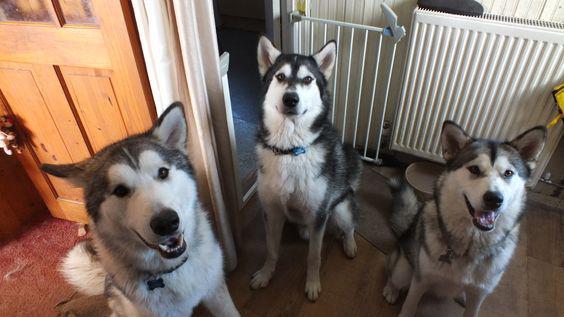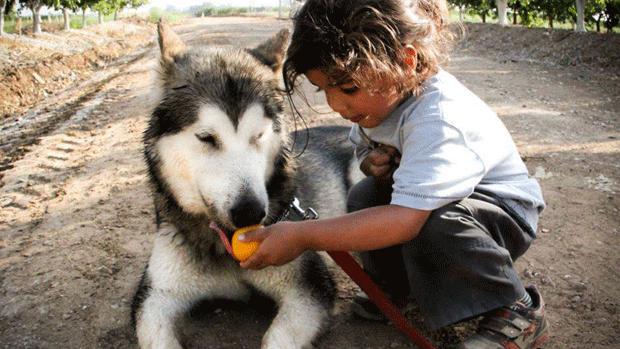The first image is the image on the left, the second image is the image on the right. Evaluate the accuracy of this statement regarding the images: "There are two dogs in the image pair". Is it true? Answer yes or no. No. The first image is the image on the left, the second image is the image on the right. Analyze the images presented: Is the assertion "There are dogs standing." valid? Answer yes or no. No. 